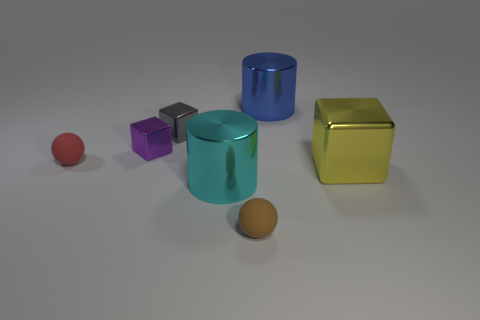Is the shape of the small purple thing the same as the small shiny thing right of the purple block?
Your response must be concise. Yes. There is a tiny thing to the right of the large cylinder that is in front of the blue shiny cylinder; what is it made of?
Your answer should be compact. Rubber. Are there an equal number of small objects that are to the right of the blue thing and small gray things?
Ensure brevity in your answer.  No. What number of cylinders are in front of the tiny red ball and behind the small gray thing?
Provide a short and direct response. 0. What number of other objects are the same shape as the blue object?
Ensure brevity in your answer.  1. Are there more cyan shiny objects that are on the left side of the blue shiny thing than small cyan rubber blocks?
Offer a terse response. Yes. What color is the tiny sphere that is to the left of the tiny purple metallic block?
Your response must be concise. Red. How many matte things are red things or cyan balls?
Your answer should be compact. 1. Is there a big yellow shiny object that is in front of the sphere behind the large shiny cylinder in front of the big blue shiny thing?
Make the answer very short. Yes. How many balls are behind the tiny purple cube?
Make the answer very short. 0. 